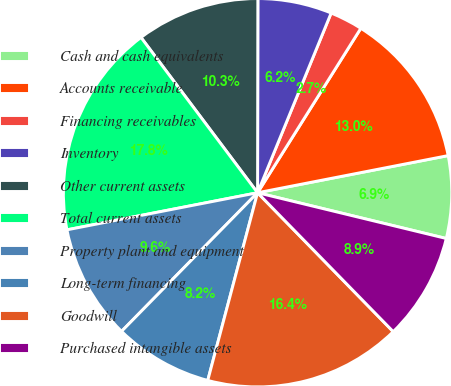Convert chart. <chart><loc_0><loc_0><loc_500><loc_500><pie_chart><fcel>Cash and cash equivalents<fcel>Accounts receivable<fcel>Financing receivables<fcel>Inventory<fcel>Other current assets<fcel>Total current assets<fcel>Property plant and equipment<fcel>Long-term financing<fcel>Goodwill<fcel>Purchased intangible assets<nl><fcel>6.85%<fcel>13.01%<fcel>2.74%<fcel>6.16%<fcel>10.27%<fcel>17.81%<fcel>9.59%<fcel>8.22%<fcel>16.44%<fcel>8.9%<nl></chart> 